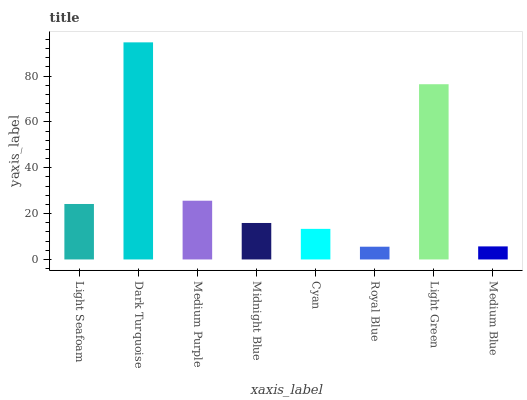Is Royal Blue the minimum?
Answer yes or no. Yes. Is Dark Turquoise the maximum?
Answer yes or no. Yes. Is Medium Purple the minimum?
Answer yes or no. No. Is Medium Purple the maximum?
Answer yes or no. No. Is Dark Turquoise greater than Medium Purple?
Answer yes or no. Yes. Is Medium Purple less than Dark Turquoise?
Answer yes or no. Yes. Is Medium Purple greater than Dark Turquoise?
Answer yes or no. No. Is Dark Turquoise less than Medium Purple?
Answer yes or no. No. Is Light Seafoam the high median?
Answer yes or no. Yes. Is Midnight Blue the low median?
Answer yes or no. Yes. Is Cyan the high median?
Answer yes or no. No. Is Cyan the low median?
Answer yes or no. No. 